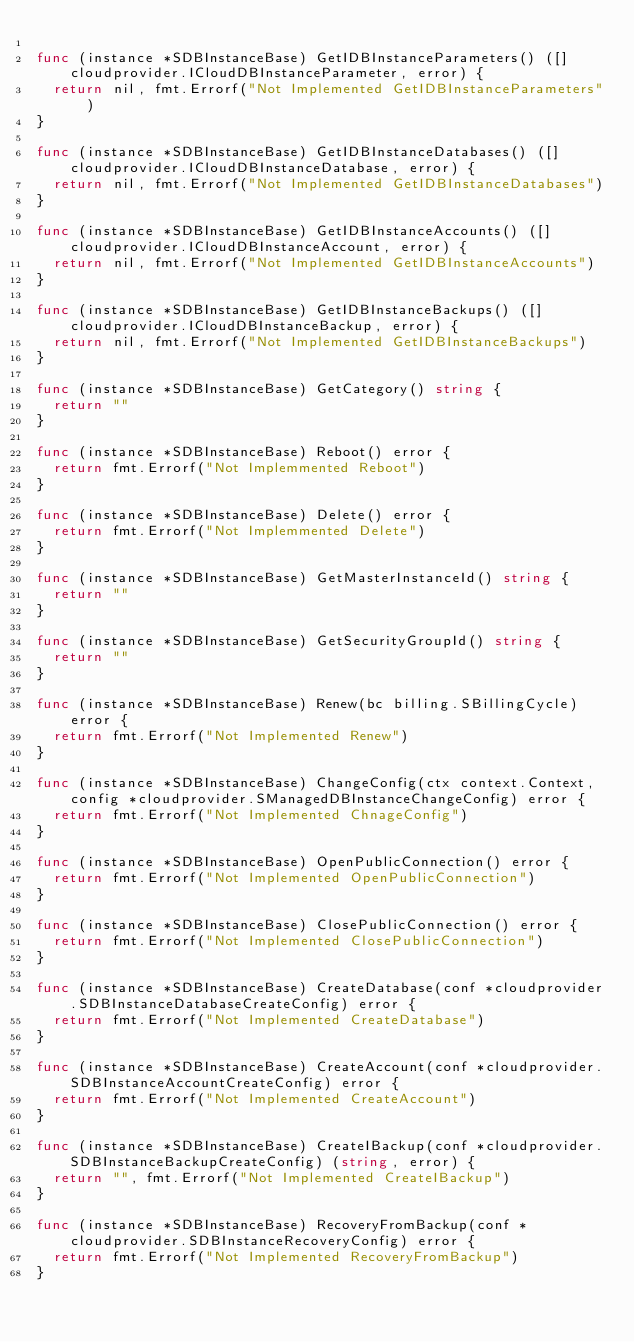Convert code to text. <code><loc_0><loc_0><loc_500><loc_500><_Go_>
func (instance *SDBInstanceBase) GetIDBInstanceParameters() ([]cloudprovider.ICloudDBInstanceParameter, error) {
	return nil, fmt.Errorf("Not Implemented GetIDBInstanceParameters")
}

func (instance *SDBInstanceBase) GetIDBInstanceDatabases() ([]cloudprovider.ICloudDBInstanceDatabase, error) {
	return nil, fmt.Errorf("Not Implemented GetIDBInstanceDatabases")
}

func (instance *SDBInstanceBase) GetIDBInstanceAccounts() ([]cloudprovider.ICloudDBInstanceAccount, error) {
	return nil, fmt.Errorf("Not Implemented GetIDBInstanceAccounts")
}

func (instance *SDBInstanceBase) GetIDBInstanceBackups() ([]cloudprovider.ICloudDBInstanceBackup, error) {
	return nil, fmt.Errorf("Not Implemented GetIDBInstanceBackups")
}

func (instance *SDBInstanceBase) GetCategory() string {
	return ""
}

func (instance *SDBInstanceBase) Reboot() error {
	return fmt.Errorf("Not Implemmented Reboot")
}

func (instance *SDBInstanceBase) Delete() error {
	return fmt.Errorf("Not Implemmented Delete")
}

func (instance *SDBInstanceBase) GetMasterInstanceId() string {
	return ""
}

func (instance *SDBInstanceBase) GetSecurityGroupId() string {
	return ""
}

func (instance *SDBInstanceBase) Renew(bc billing.SBillingCycle) error {
	return fmt.Errorf("Not Implemented Renew")
}

func (instance *SDBInstanceBase) ChangeConfig(ctx context.Context, config *cloudprovider.SManagedDBInstanceChangeConfig) error {
	return fmt.Errorf("Not Implemented ChnageConfig")
}

func (instance *SDBInstanceBase) OpenPublicConnection() error {
	return fmt.Errorf("Not Implemented OpenPublicConnection")
}

func (instance *SDBInstanceBase) ClosePublicConnection() error {
	return fmt.Errorf("Not Implemented ClosePublicConnection")
}

func (instance *SDBInstanceBase) CreateDatabase(conf *cloudprovider.SDBInstanceDatabaseCreateConfig) error {
	return fmt.Errorf("Not Implemented CreateDatabase")
}

func (instance *SDBInstanceBase) CreateAccount(conf *cloudprovider.SDBInstanceAccountCreateConfig) error {
	return fmt.Errorf("Not Implemented CreateAccount")
}

func (instance *SDBInstanceBase) CreateIBackup(conf *cloudprovider.SDBInstanceBackupCreateConfig) (string, error) {
	return "", fmt.Errorf("Not Implemented CreateIBackup")
}

func (instance *SDBInstanceBase) RecoveryFromBackup(conf *cloudprovider.SDBInstanceRecoveryConfig) error {
	return fmt.Errorf("Not Implemented RecoveryFromBackup")
}
</code> 